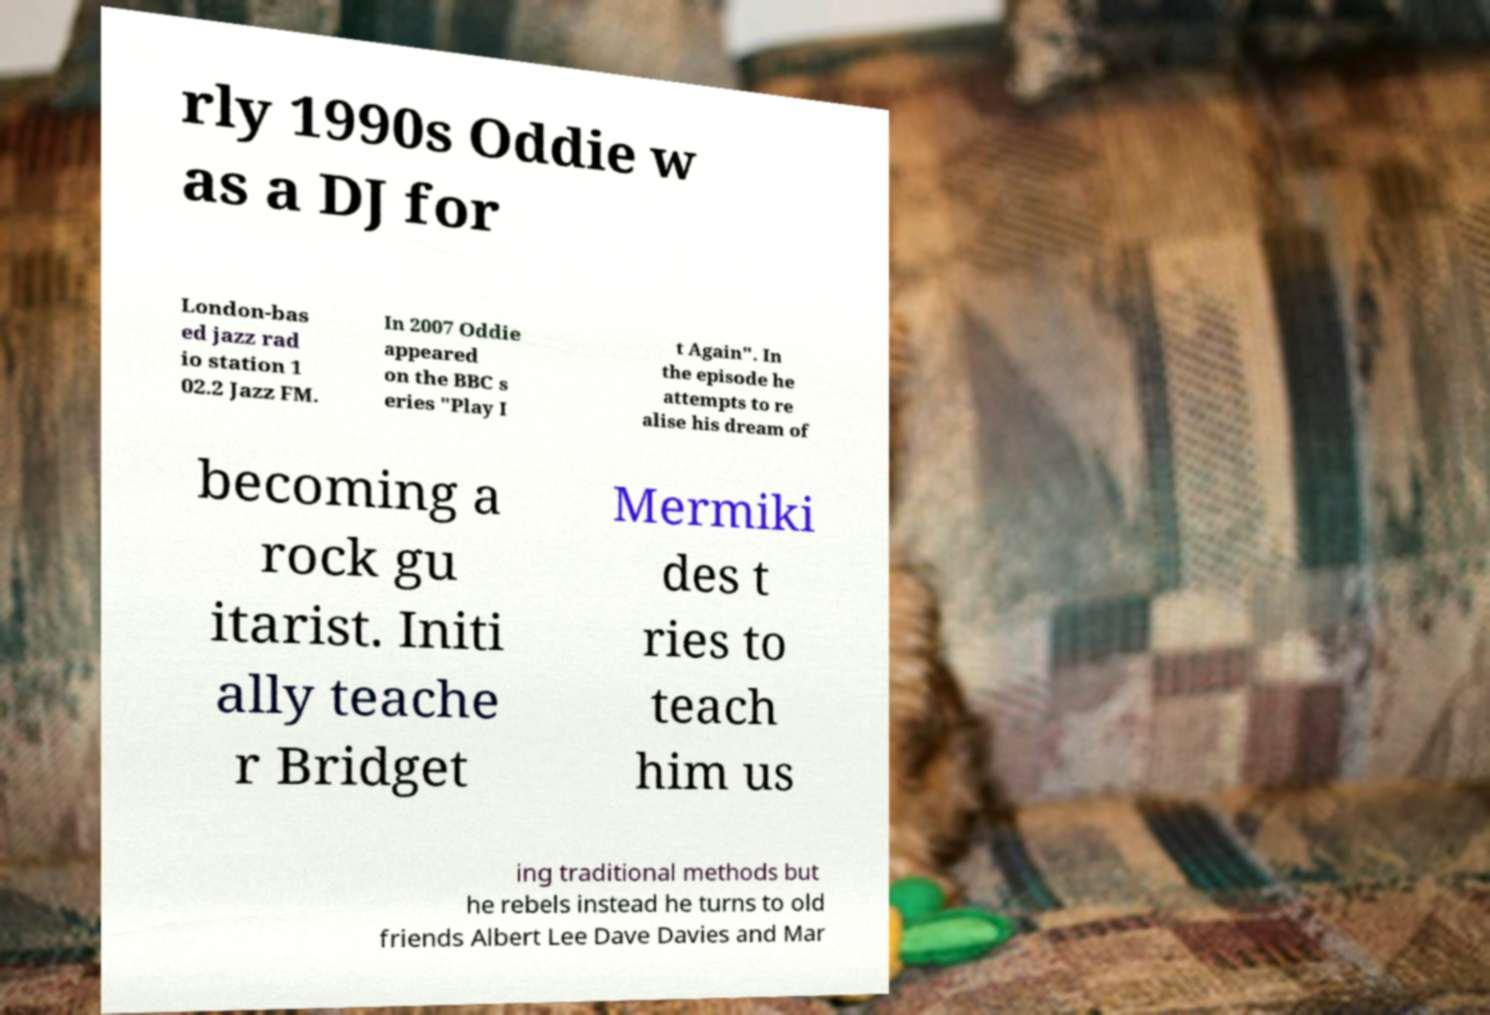I need the written content from this picture converted into text. Can you do that? rly 1990s Oddie w as a DJ for London-bas ed jazz rad io station 1 02.2 Jazz FM. In 2007 Oddie appeared on the BBC s eries "Play I t Again". In the episode he attempts to re alise his dream of becoming a rock gu itarist. Initi ally teache r Bridget Mermiki des t ries to teach him us ing traditional methods but he rebels instead he turns to old friends Albert Lee Dave Davies and Mar 